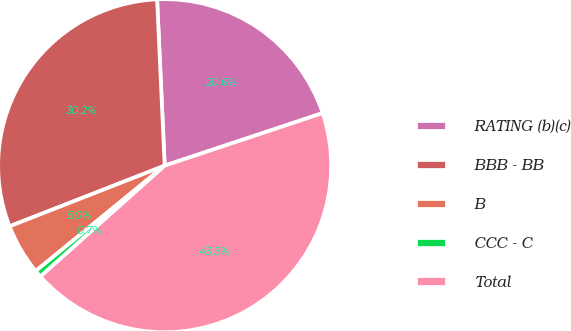Convert chart to OTSL. <chart><loc_0><loc_0><loc_500><loc_500><pie_chart><fcel>RATING (b)(c)<fcel>BBB - BB<fcel>B<fcel>CCC - C<fcel>Total<nl><fcel>20.61%<fcel>30.21%<fcel>4.97%<fcel>0.69%<fcel>43.52%<nl></chart> 